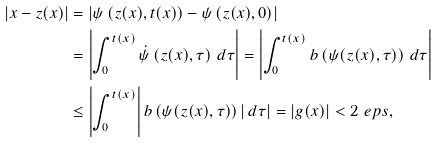<formula> <loc_0><loc_0><loc_500><loc_500>| x - z ( x ) | & = \left | \psi \left ( z ( x ) , t ( x ) \right ) - \psi \left ( z ( x ) , 0 \right ) \right | \\ & = \left | \int _ { 0 } ^ { t ( x ) } \dot { \psi } \left ( z ( x ) , \tau \right ) \, d \tau \right | = \left | \int _ { 0 } ^ { t ( x ) } b \left ( \psi ( z ( x ) , \tau ) \right ) \, d \tau \right | \\ & \leq \left | \int _ { 0 } ^ { t ( x ) } \right | b \left ( \psi ( z ( x ) , \tau ) \right ) \left | \, d \tau \right | = | g ( x ) | < 2 \ e p s ,</formula> 